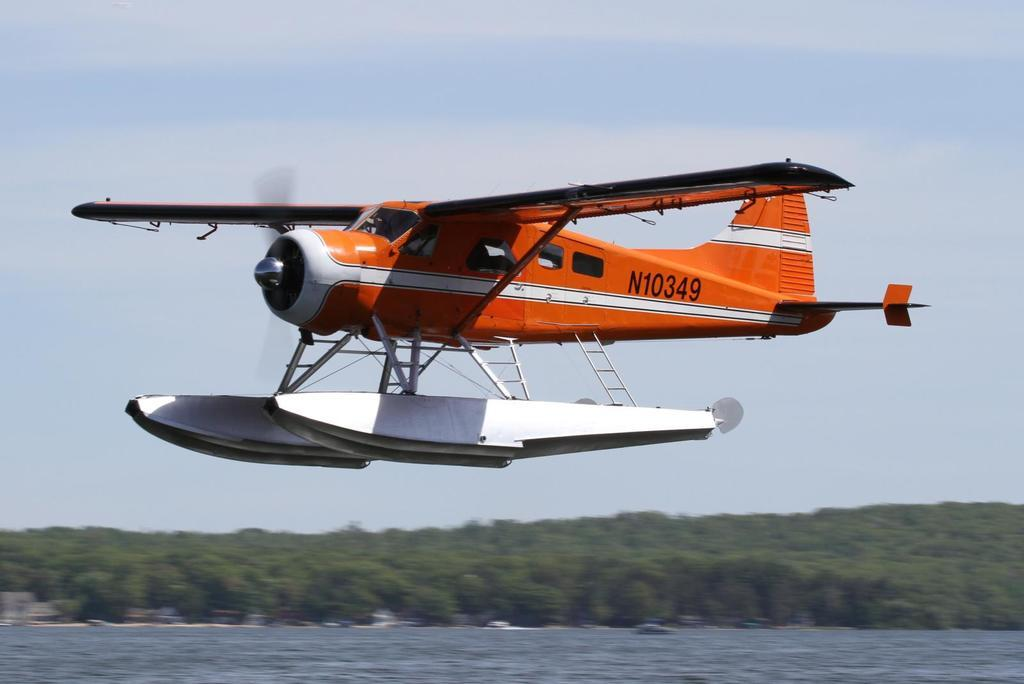<image>
Give a short and clear explanation of the subsequent image. An orange plane taking off from the water with the I.D. N10349. 